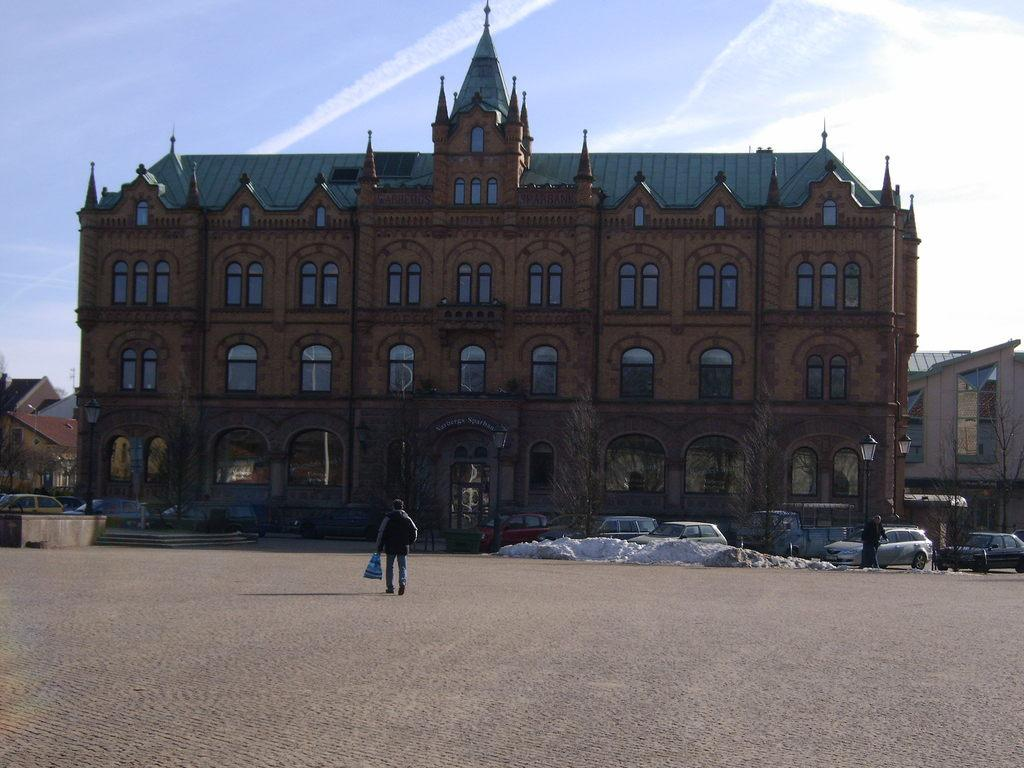How many people are in the image? There are two persons standing in the image. What is blocking the path in the image? Cars are parked on the path in the image. What type of natural elements can be seen in the image? There are trees in the image. What type of artificial elements can be seen in the image? Lights and buildings are visible in the image. What part of the natural environment is visible in the image? The sky is visible in the image. What type of desk is visible in the image? There is no desk present in the image. Are the persons in the image crying? There is no indication in the image that the persons are crying. 